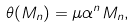<formula> <loc_0><loc_0><loc_500><loc_500>\theta ( M _ { n } ) = \mu \alpha ^ { n } M _ { n } ,</formula> 